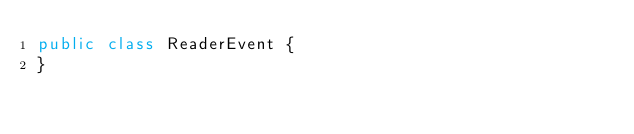<code> <loc_0><loc_0><loc_500><loc_500><_Java_>public class ReaderEvent {
}
</code> 